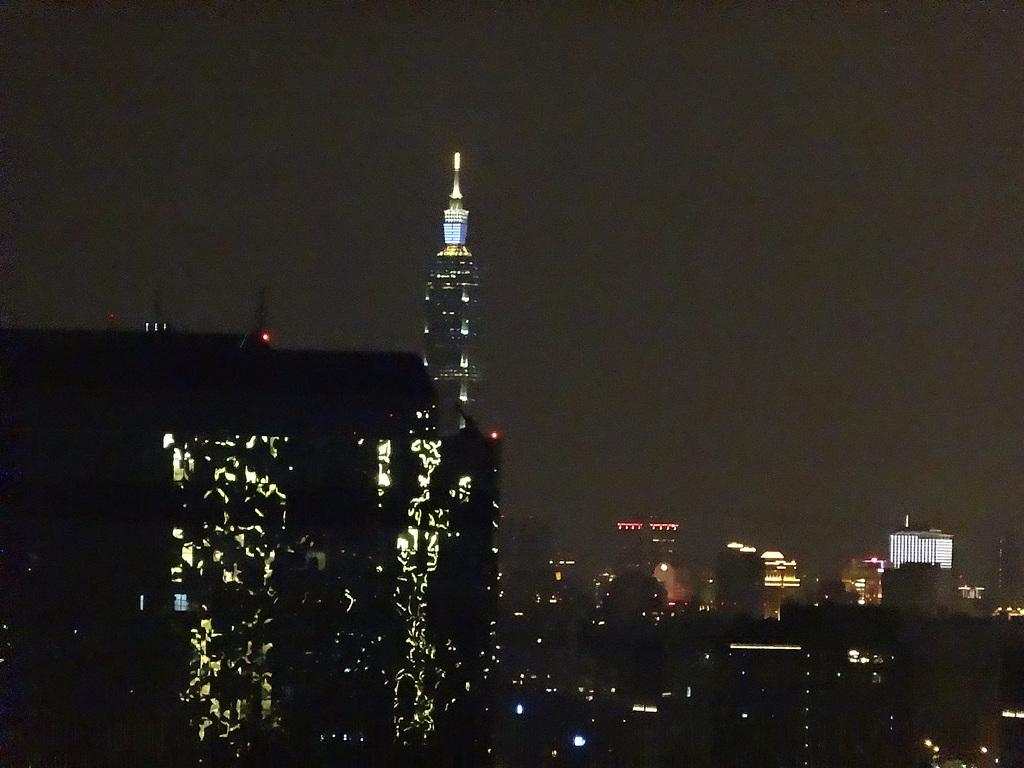What type of structures are present in the image? There is a group of buildings in the image. What feature do the buildings have? The buildings have lights. What can be seen in the background of the image? The sky is visible in the background of the image. What type of record can be seen playing on a turntable in the image? There is no record or turntable present in the image; it features a group of buildings with lights and a visible sky in the background. 